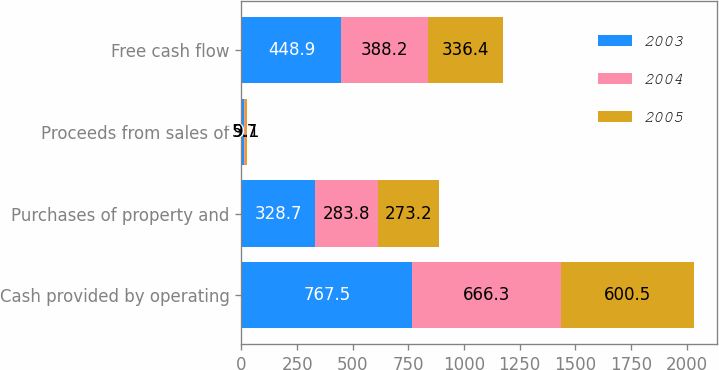<chart> <loc_0><loc_0><loc_500><loc_500><stacked_bar_chart><ecel><fcel>Cash provided by operating<fcel>Purchases of property and<fcel>Proceeds from sales of<fcel>Free cash flow<nl><fcel>2003<fcel>767.5<fcel>328.7<fcel>10.1<fcel>448.9<nl><fcel>2004<fcel>666.3<fcel>283.8<fcel>5.7<fcel>388.2<nl><fcel>2005<fcel>600.5<fcel>273.2<fcel>9.1<fcel>336.4<nl></chart> 